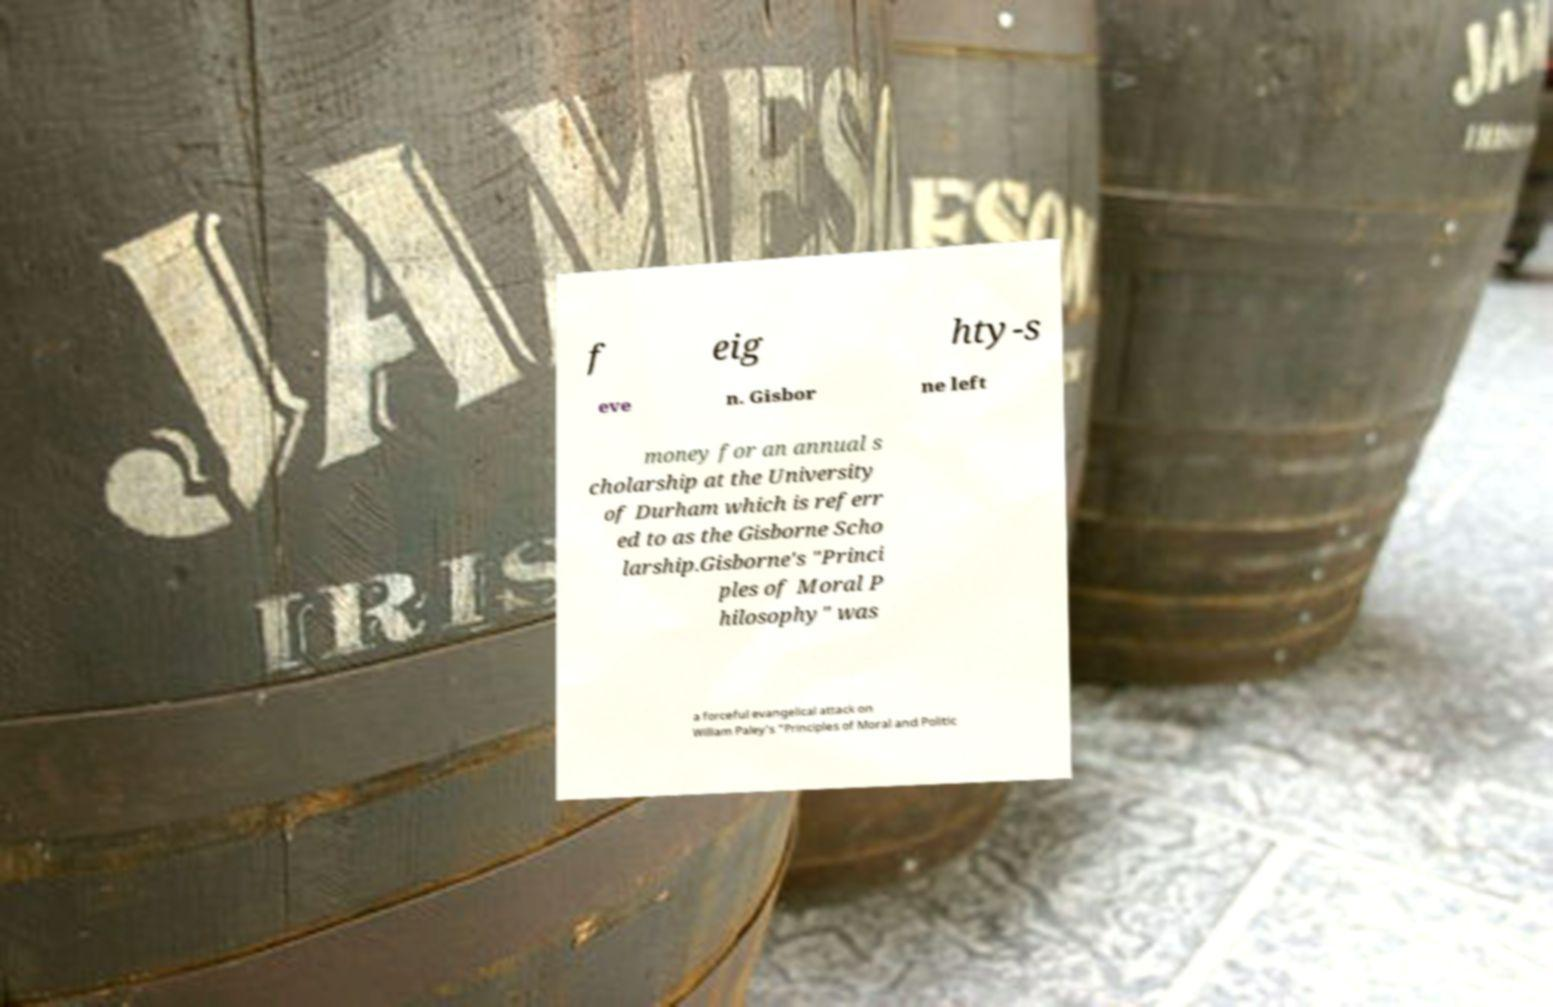Can you read and provide the text displayed in the image?This photo seems to have some interesting text. Can you extract and type it out for me? f eig hty-s eve n. Gisbor ne left money for an annual s cholarship at the University of Durham which is referr ed to as the Gisborne Scho larship.Gisborne's "Princi ples of Moral P hilosophy" was a forceful evangelical attack on William Paley's "Principles of Moral and Politic 